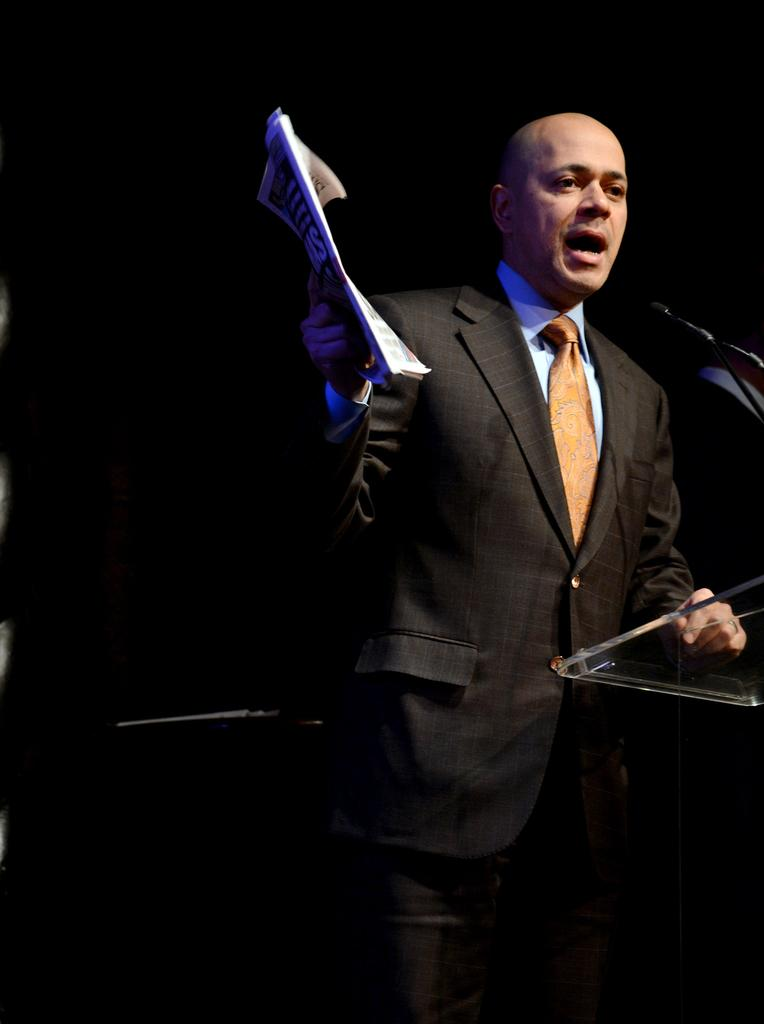Who is present in the image? There is a man in the image. What is the man standing beside? The man is standing beside a speaker stand. What is the man holding in the image? The man is holding some papers. What other equipment can be seen in the image? There is a mic with a stand in the image. What type of trees can be seen in the cemetery in the image? There is no cemetery or trees present in the image; it features a man standing beside a speaker stand and holding papers. 